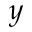Convert formula to latex. <formula><loc_0><loc_0><loc_500><loc_500>y</formula> 